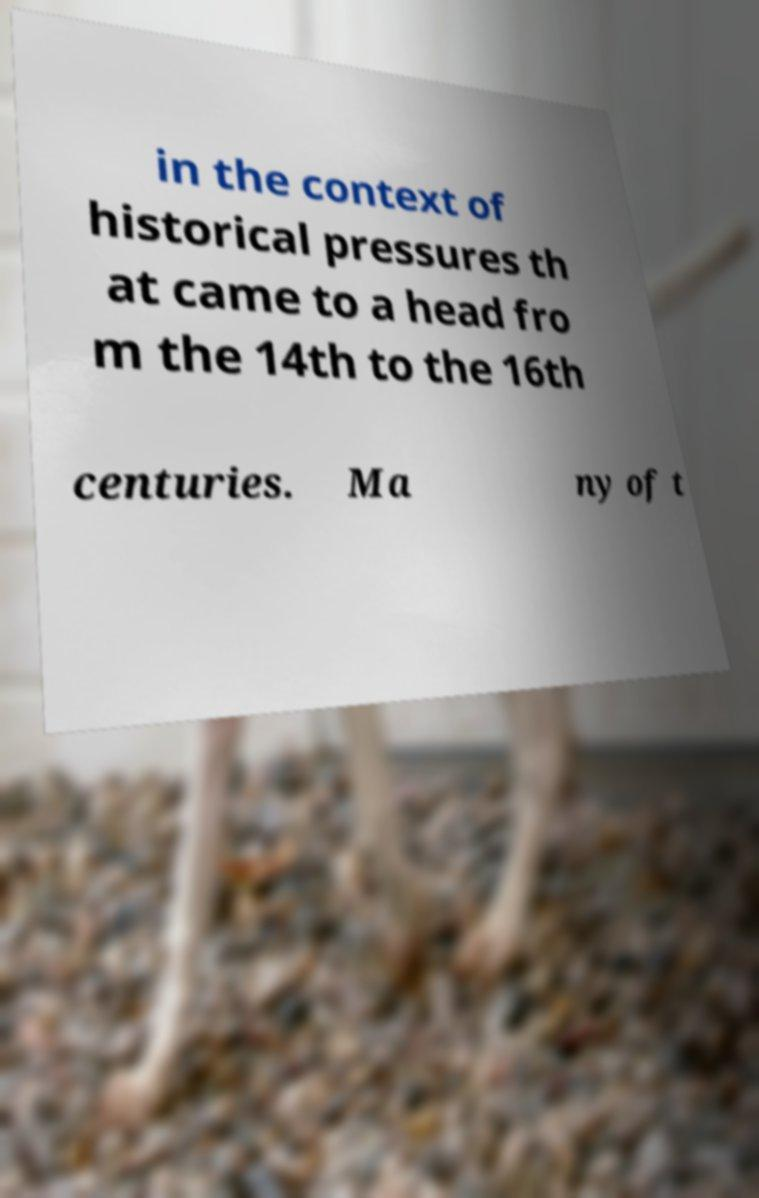Can you accurately transcribe the text from the provided image for me? in the context of historical pressures th at came to a head fro m the 14th to the 16th centuries. Ma ny of t 